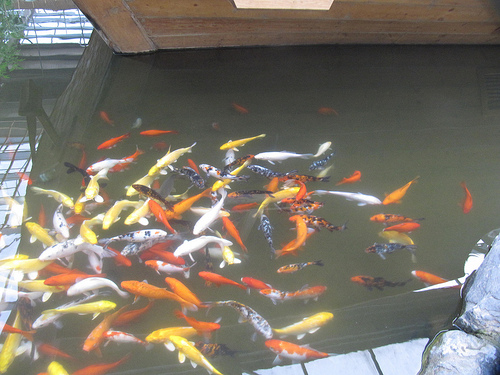<image>
Is there a fish in the water? Yes. The fish is contained within or inside the water, showing a containment relationship. 